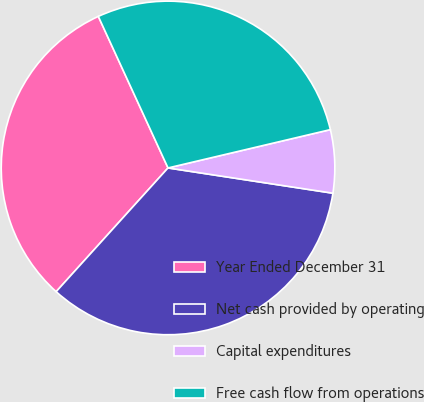Convert chart to OTSL. <chart><loc_0><loc_0><loc_500><loc_500><pie_chart><fcel>Year Ended December 31<fcel>Net cash provided by operating<fcel>Capital expenditures<fcel>Free cash flow from operations<nl><fcel>31.44%<fcel>34.28%<fcel>6.11%<fcel>28.17%<nl></chart> 